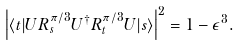Convert formula to latex. <formula><loc_0><loc_0><loc_500><loc_500>\left | \langle t | U R _ { s } ^ { \pi / 3 } U ^ { \dagger } R _ { t } ^ { \pi / 3 } U | s \rangle \right | ^ { 2 } = 1 - \epsilon ^ { 3 } .</formula> 